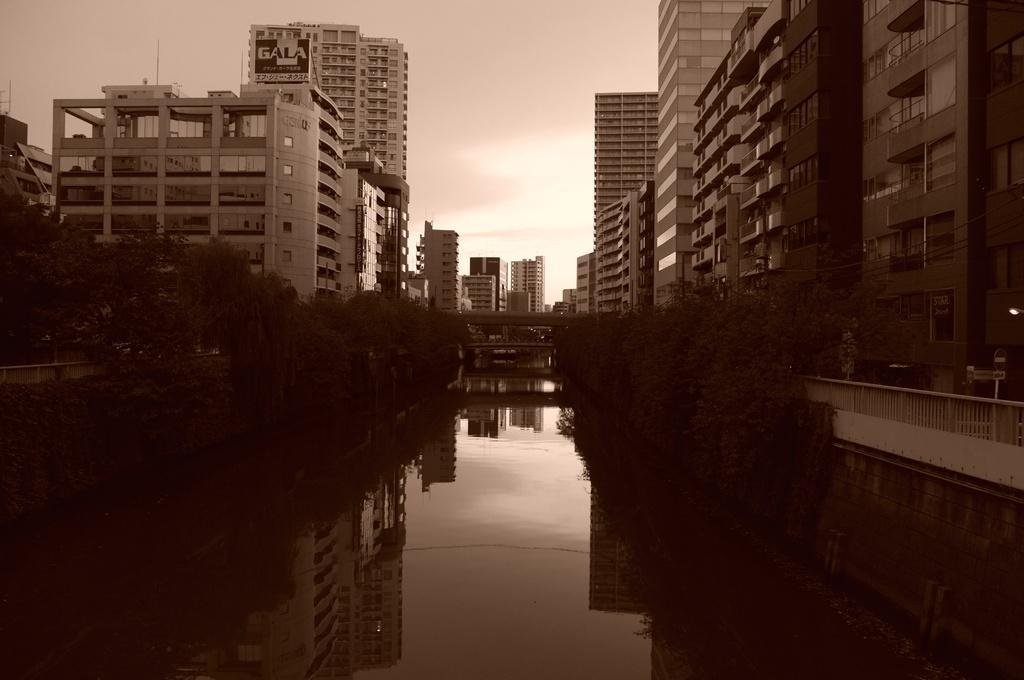Can you describe this image briefly? In front of the image there is water, on the water, there is a bridge, besides the water there are trees and metal rod fence. On the other side of the fence there are sign boards, lamp posts and buildings. On top of the building there are antennas and billboard. At the top of the image there are clouds in the sky. 